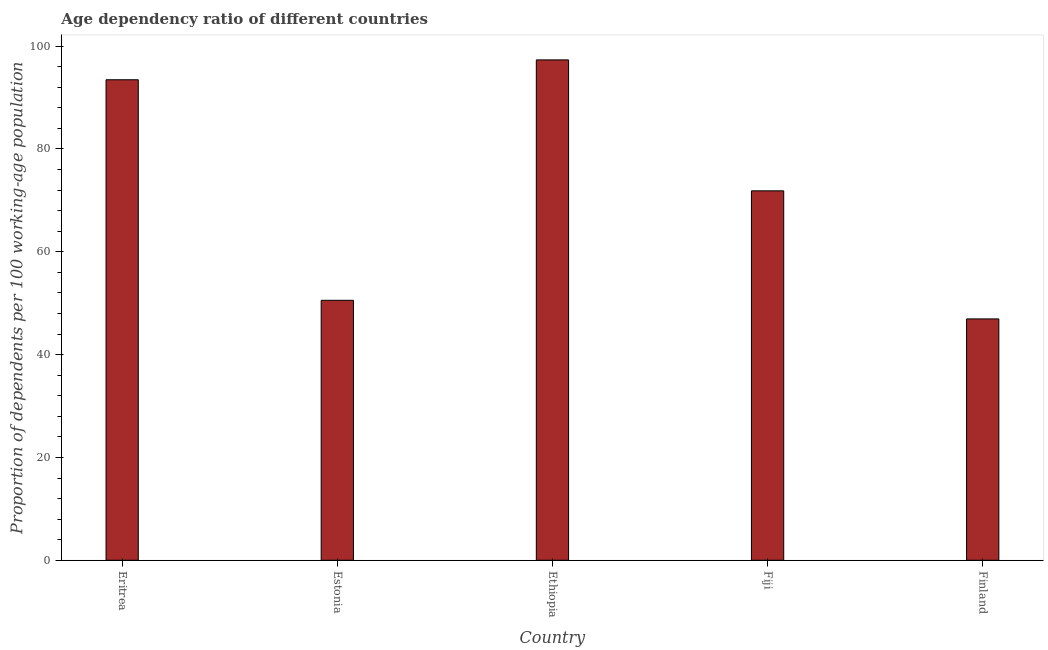What is the title of the graph?
Offer a very short reply. Age dependency ratio of different countries. What is the label or title of the X-axis?
Ensure brevity in your answer.  Country. What is the label or title of the Y-axis?
Provide a succinct answer. Proportion of dependents per 100 working-age population. What is the age dependency ratio in Estonia?
Keep it short and to the point. 50.56. Across all countries, what is the maximum age dependency ratio?
Your answer should be very brief. 97.33. Across all countries, what is the minimum age dependency ratio?
Provide a short and direct response. 46.94. In which country was the age dependency ratio maximum?
Keep it short and to the point. Ethiopia. In which country was the age dependency ratio minimum?
Your answer should be very brief. Finland. What is the sum of the age dependency ratio?
Provide a succinct answer. 360.16. What is the difference between the age dependency ratio in Estonia and Finland?
Keep it short and to the point. 3.62. What is the average age dependency ratio per country?
Provide a succinct answer. 72.03. What is the median age dependency ratio?
Your answer should be very brief. 71.86. In how many countries, is the age dependency ratio greater than 36 ?
Ensure brevity in your answer.  5. What is the ratio of the age dependency ratio in Eritrea to that in Finland?
Your answer should be very brief. 1.99. Is the age dependency ratio in Eritrea less than that in Finland?
Your answer should be compact. No. Is the difference between the age dependency ratio in Eritrea and Finland greater than the difference between any two countries?
Offer a terse response. No. What is the difference between the highest and the second highest age dependency ratio?
Your answer should be very brief. 3.87. Is the sum of the age dependency ratio in Eritrea and Finland greater than the maximum age dependency ratio across all countries?
Make the answer very short. Yes. What is the difference between the highest and the lowest age dependency ratio?
Ensure brevity in your answer.  50.38. How many bars are there?
Your response must be concise. 5. How many countries are there in the graph?
Offer a very short reply. 5. What is the Proportion of dependents per 100 working-age population in Eritrea?
Your answer should be compact. 93.46. What is the Proportion of dependents per 100 working-age population of Estonia?
Offer a terse response. 50.56. What is the Proportion of dependents per 100 working-age population in Ethiopia?
Ensure brevity in your answer.  97.33. What is the Proportion of dependents per 100 working-age population of Fiji?
Offer a very short reply. 71.86. What is the Proportion of dependents per 100 working-age population of Finland?
Make the answer very short. 46.94. What is the difference between the Proportion of dependents per 100 working-age population in Eritrea and Estonia?
Offer a very short reply. 42.9. What is the difference between the Proportion of dependents per 100 working-age population in Eritrea and Ethiopia?
Offer a terse response. -3.86. What is the difference between the Proportion of dependents per 100 working-age population in Eritrea and Fiji?
Keep it short and to the point. 21.61. What is the difference between the Proportion of dependents per 100 working-age population in Eritrea and Finland?
Your response must be concise. 46.52. What is the difference between the Proportion of dependents per 100 working-age population in Estonia and Ethiopia?
Ensure brevity in your answer.  -46.76. What is the difference between the Proportion of dependents per 100 working-age population in Estonia and Fiji?
Give a very brief answer. -21.29. What is the difference between the Proportion of dependents per 100 working-age population in Estonia and Finland?
Make the answer very short. 3.62. What is the difference between the Proportion of dependents per 100 working-age population in Ethiopia and Fiji?
Provide a succinct answer. 25.47. What is the difference between the Proportion of dependents per 100 working-age population in Ethiopia and Finland?
Offer a very short reply. 50.38. What is the difference between the Proportion of dependents per 100 working-age population in Fiji and Finland?
Offer a terse response. 24.91. What is the ratio of the Proportion of dependents per 100 working-age population in Eritrea to that in Estonia?
Give a very brief answer. 1.85. What is the ratio of the Proportion of dependents per 100 working-age population in Eritrea to that in Fiji?
Give a very brief answer. 1.3. What is the ratio of the Proportion of dependents per 100 working-age population in Eritrea to that in Finland?
Your response must be concise. 1.99. What is the ratio of the Proportion of dependents per 100 working-age population in Estonia to that in Ethiopia?
Provide a short and direct response. 0.52. What is the ratio of the Proportion of dependents per 100 working-age population in Estonia to that in Fiji?
Ensure brevity in your answer.  0.7. What is the ratio of the Proportion of dependents per 100 working-age population in Estonia to that in Finland?
Offer a terse response. 1.08. What is the ratio of the Proportion of dependents per 100 working-age population in Ethiopia to that in Fiji?
Your answer should be compact. 1.35. What is the ratio of the Proportion of dependents per 100 working-age population in Ethiopia to that in Finland?
Make the answer very short. 2.07. What is the ratio of the Proportion of dependents per 100 working-age population in Fiji to that in Finland?
Provide a short and direct response. 1.53. 